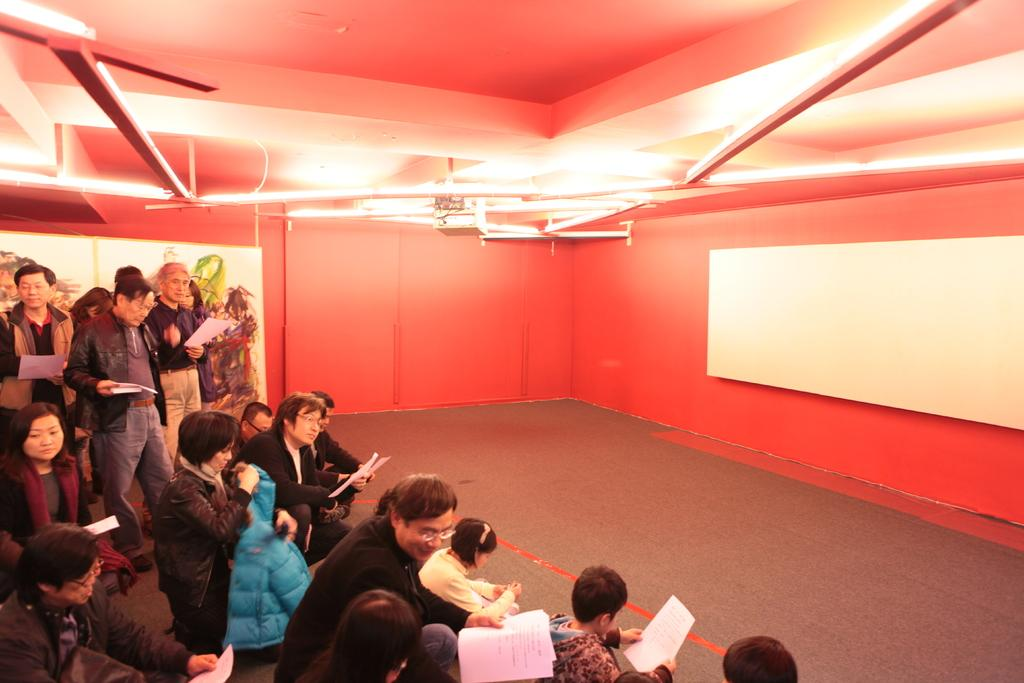What are the people in the image holding? The people in the image are holding papers. What can be seen illuminating the scene in the image? There are lights visible in the image. What is the color of the wall in the image? The wall in the image is orange-colored. What is attached to the orange-colored wall in the image? There are boards attached to the orange-colored wall in the image. How many clams are sitting on the boards in the image? There are no clams present in the image; the boards are attached to an orange-colored wall. 